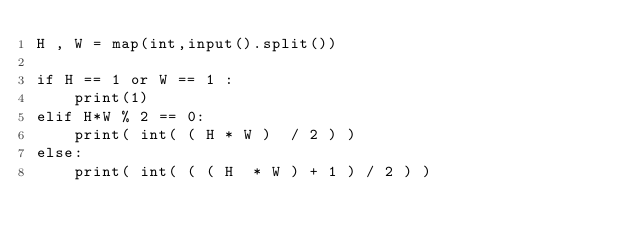Convert code to text. <code><loc_0><loc_0><loc_500><loc_500><_Python_>H , W = map(int,input().split())

if H == 1 or W == 1 :
    print(1)
elif H*W % 2 == 0:
    print( int( ( H * W )  / 2 ) )
else:
    print( int( ( ( H  * W ) + 1 ) / 2 ) )</code> 